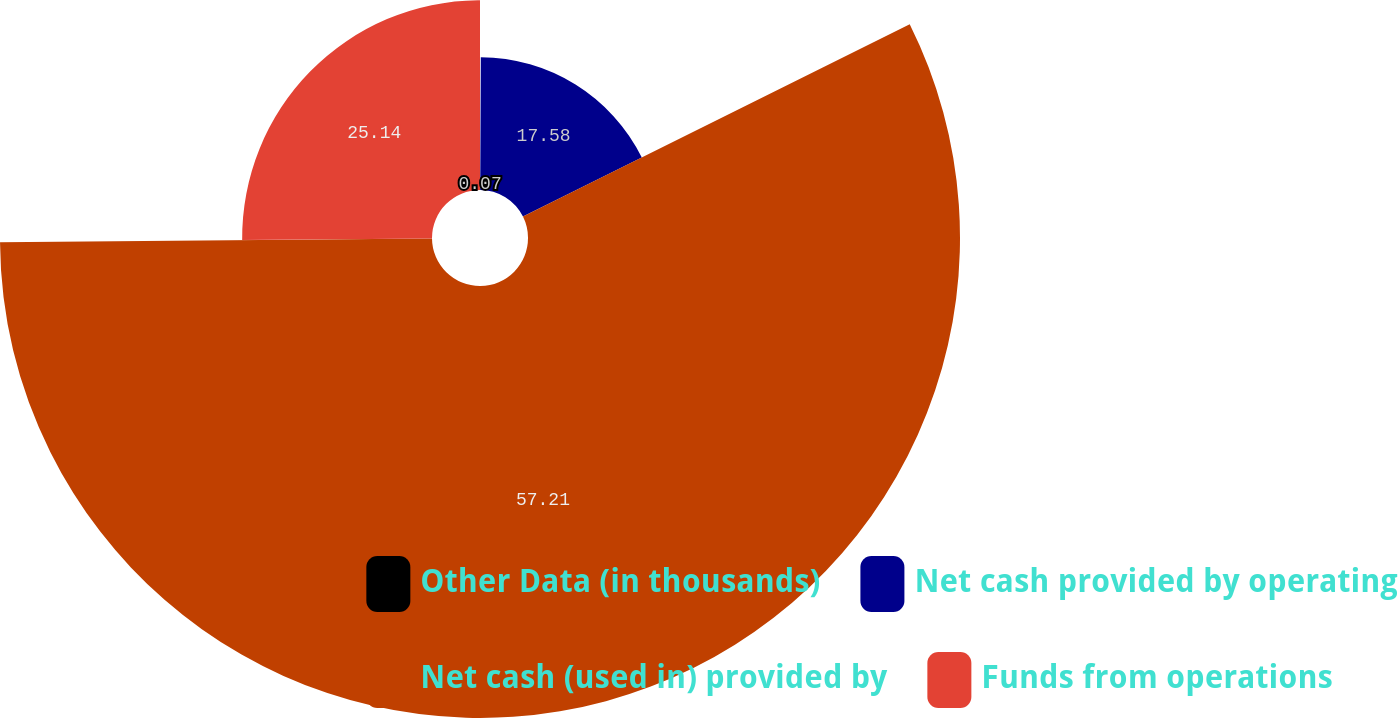Convert chart. <chart><loc_0><loc_0><loc_500><loc_500><pie_chart><fcel>Other Data (in thousands)<fcel>Net cash provided by operating<fcel>Net cash (used in) provided by<fcel>Funds from operations<nl><fcel>0.07%<fcel>17.58%<fcel>57.21%<fcel>25.14%<nl></chart> 